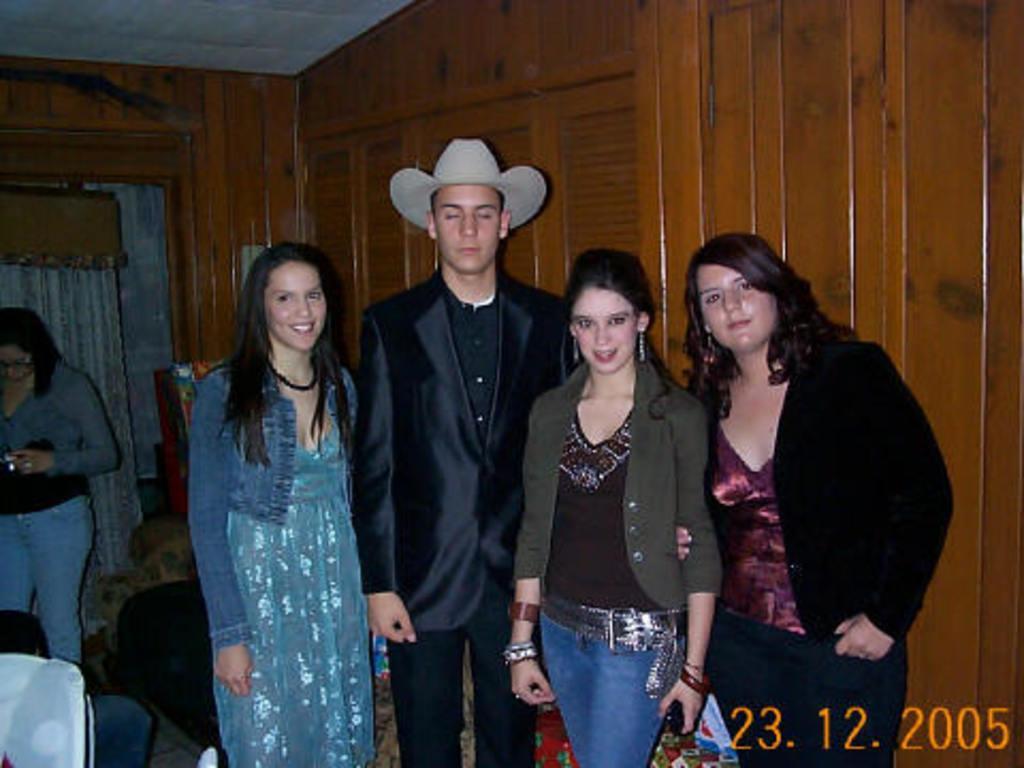Describe this image in one or two sentences. In the image we can see four women and a man is standing, they are wearing clothes and three of them are smiling. The man is wearing a hat and two women are wearing earrings. Here we can see wooden wall and the curtains. On the bottom right we can see watermark. 